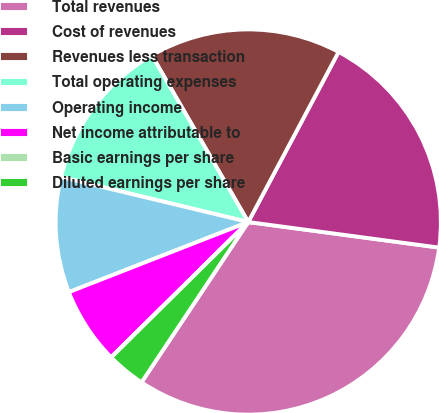Convert chart. <chart><loc_0><loc_0><loc_500><loc_500><pie_chart><fcel>Total revenues<fcel>Cost of revenues<fcel>Revenues less transaction<fcel>Total operating expenses<fcel>Operating income<fcel>Net income attributable to<fcel>Basic earnings per share<fcel>Diluted earnings per share<nl><fcel>32.23%<fcel>19.35%<fcel>16.12%<fcel>12.9%<fcel>9.68%<fcel>6.46%<fcel>0.02%<fcel>3.24%<nl></chart> 